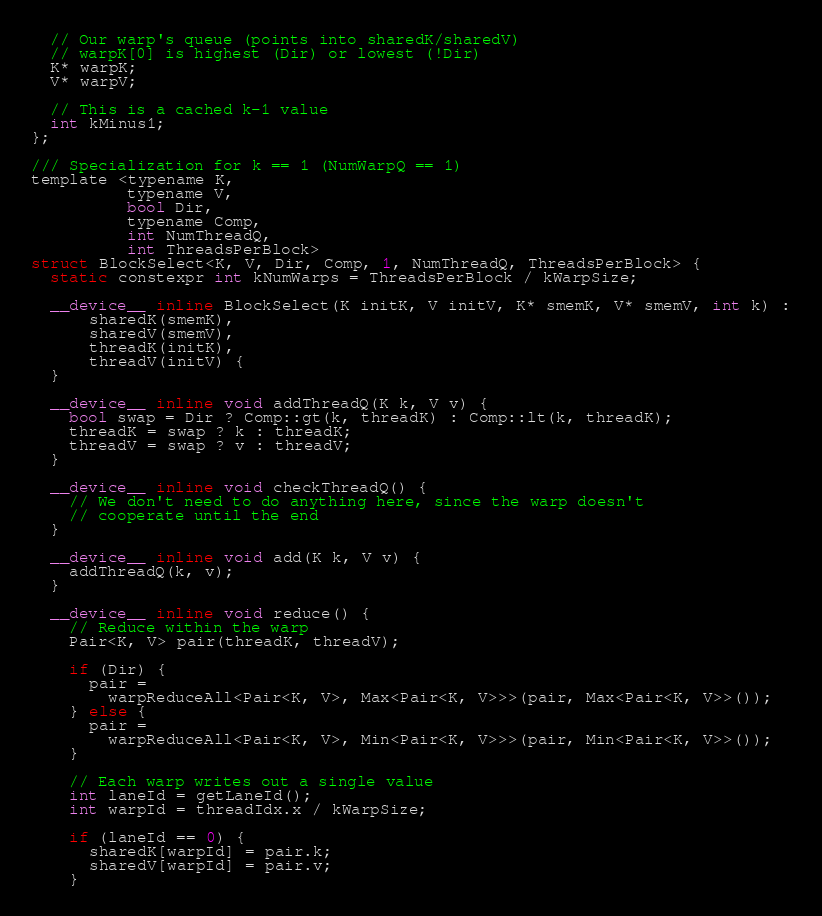<code> <loc_0><loc_0><loc_500><loc_500><_Cuda_>
  // Our warp's queue (points into sharedK/sharedV)
  // warpK[0] is highest (Dir) or lowest (!Dir)
  K* warpK;
  V* warpV;

  // This is a cached k-1 value
  int kMinus1;
};

/// Specialization for k == 1 (NumWarpQ == 1)
template <typename K,
          typename V,
          bool Dir,
          typename Comp,
          int NumThreadQ,
          int ThreadsPerBlock>
struct BlockSelect<K, V, Dir, Comp, 1, NumThreadQ, ThreadsPerBlock> {
  static constexpr int kNumWarps = ThreadsPerBlock / kWarpSize;

  __device__ inline BlockSelect(K initK, V initV, K* smemK, V* smemV, int k) :
      sharedK(smemK),
      sharedV(smemV),
      threadK(initK),
      threadV(initV) {
  }

  __device__ inline void addThreadQ(K k, V v) {
    bool swap = Dir ? Comp::gt(k, threadK) : Comp::lt(k, threadK);
    threadK = swap ? k : threadK;
    threadV = swap ? v : threadV;
  }

  __device__ inline void checkThreadQ() {
    // We don't need to do anything here, since the warp doesn't
    // cooperate until the end
  }

  __device__ inline void add(K k, V v) {
    addThreadQ(k, v);
  }

  __device__ inline void reduce() {
    // Reduce within the warp
    Pair<K, V> pair(threadK, threadV);

    if (Dir) {
      pair =
        warpReduceAll<Pair<K, V>, Max<Pair<K, V>>>(pair, Max<Pair<K, V>>());
    } else {
      pair =
        warpReduceAll<Pair<K, V>, Min<Pair<K, V>>>(pair, Min<Pair<K, V>>());
    }

    // Each warp writes out a single value
    int laneId = getLaneId();
    int warpId = threadIdx.x / kWarpSize;

    if (laneId == 0) {
      sharedK[warpId] = pair.k;
      sharedV[warpId] = pair.v;
    }
</code> 